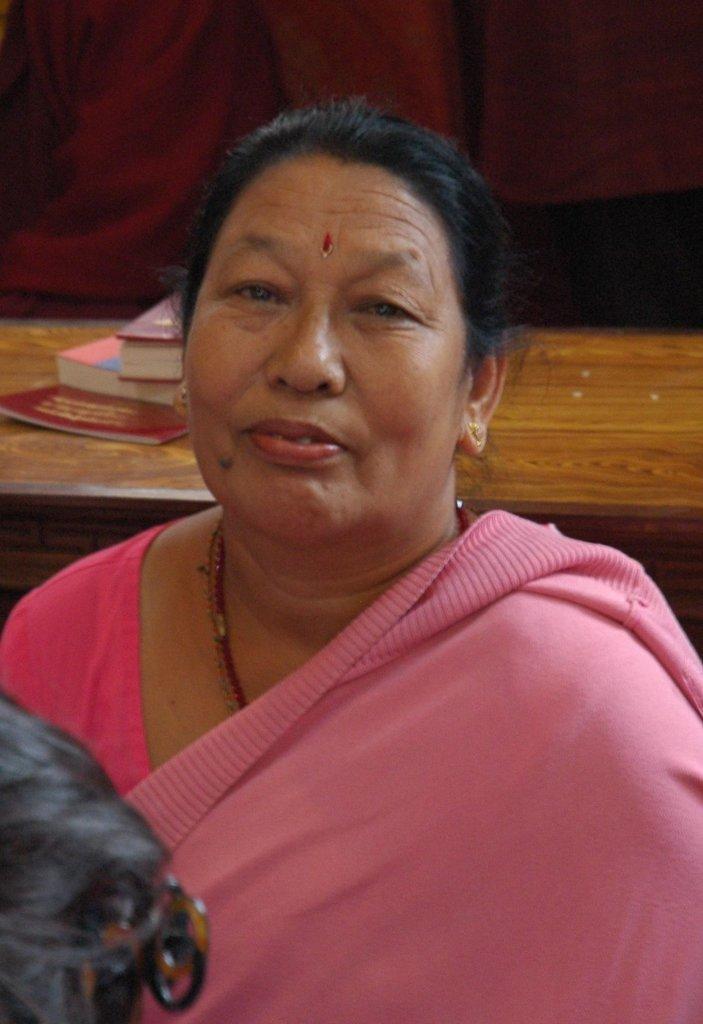Describe this image in one or two sentences. In this picture, there is a woman wearing a pink saree. Behind her, there is a table. On the table, there are books. 